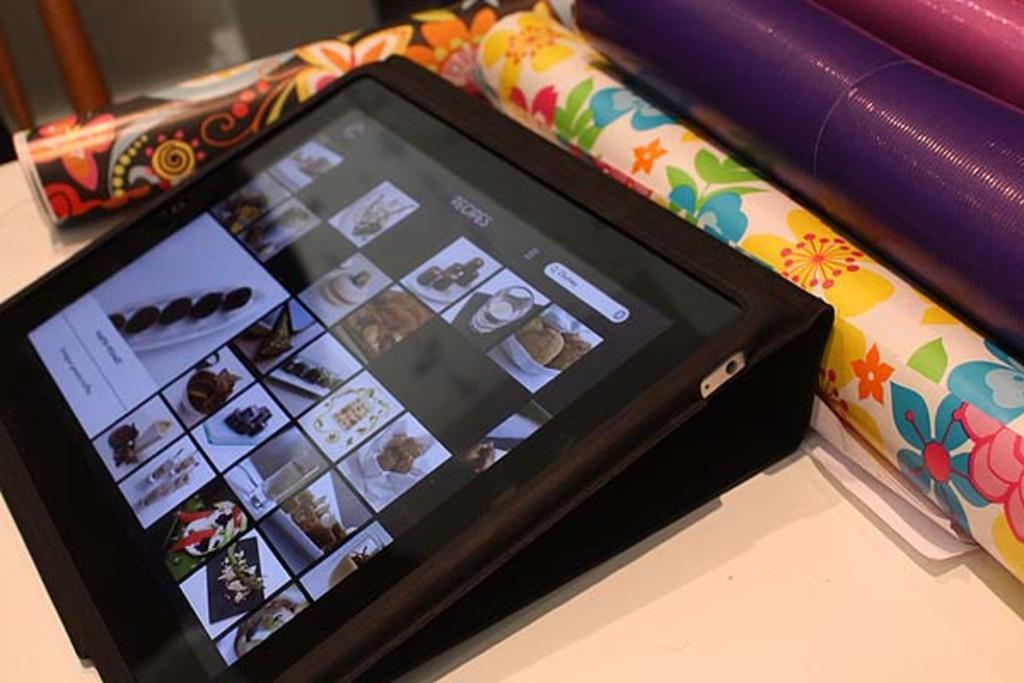How would you summarize this image in a sentence or two? There is a tab having screen which is having images. Beside this, there are rolls arranged on the table. 